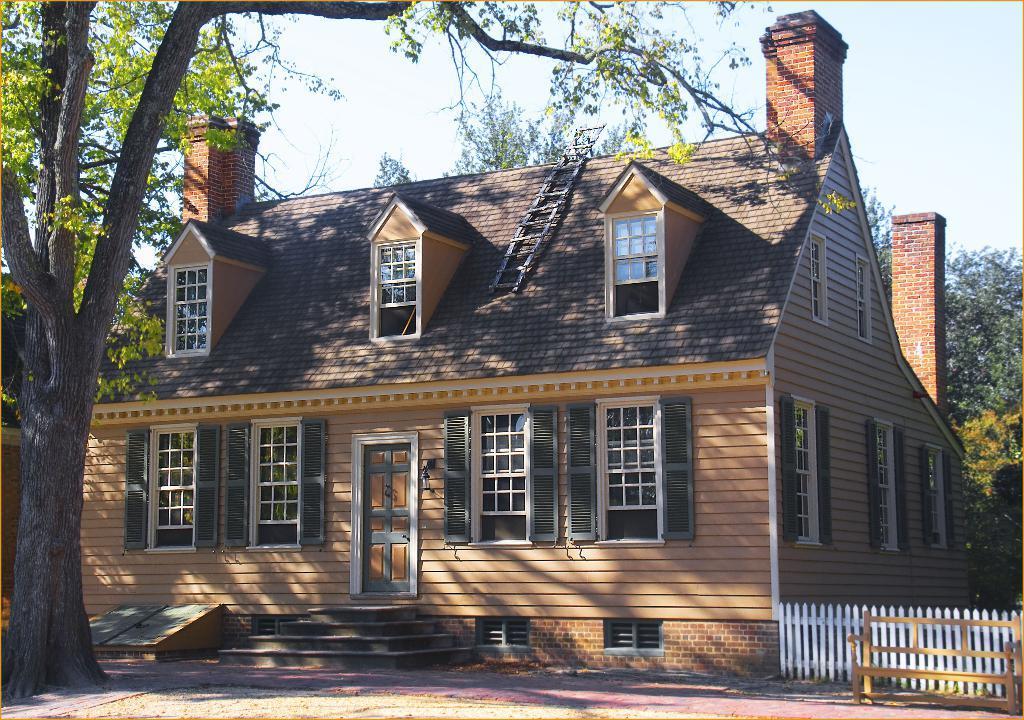Describe this image in one or two sentences. In this image we can see wooden house, ladder on the roof, steps, road, wooden fence, wooden bench, trees and the sky in the background. 